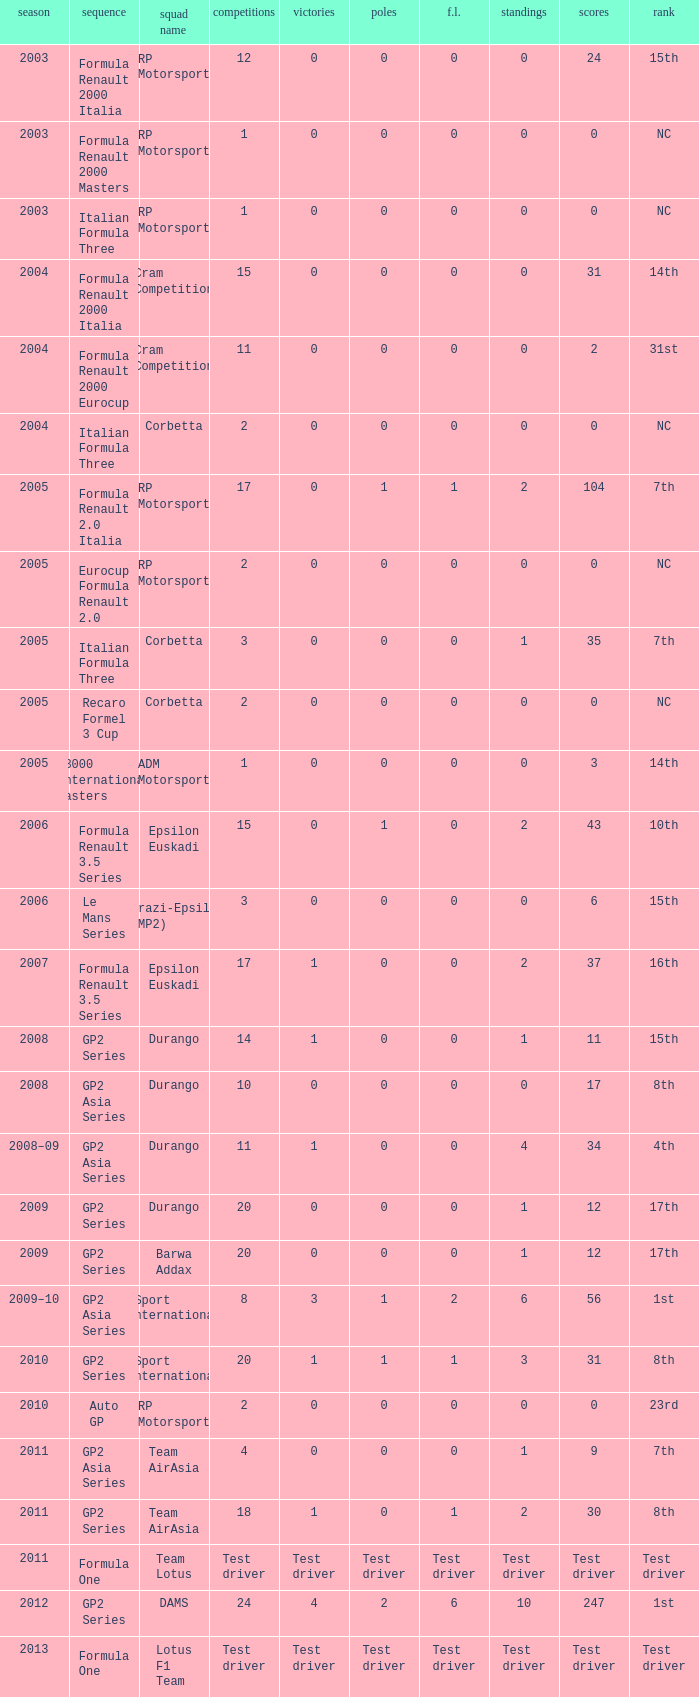What contests include gp2 series, 0 f.l. and a 17th spot? 20, 20. 